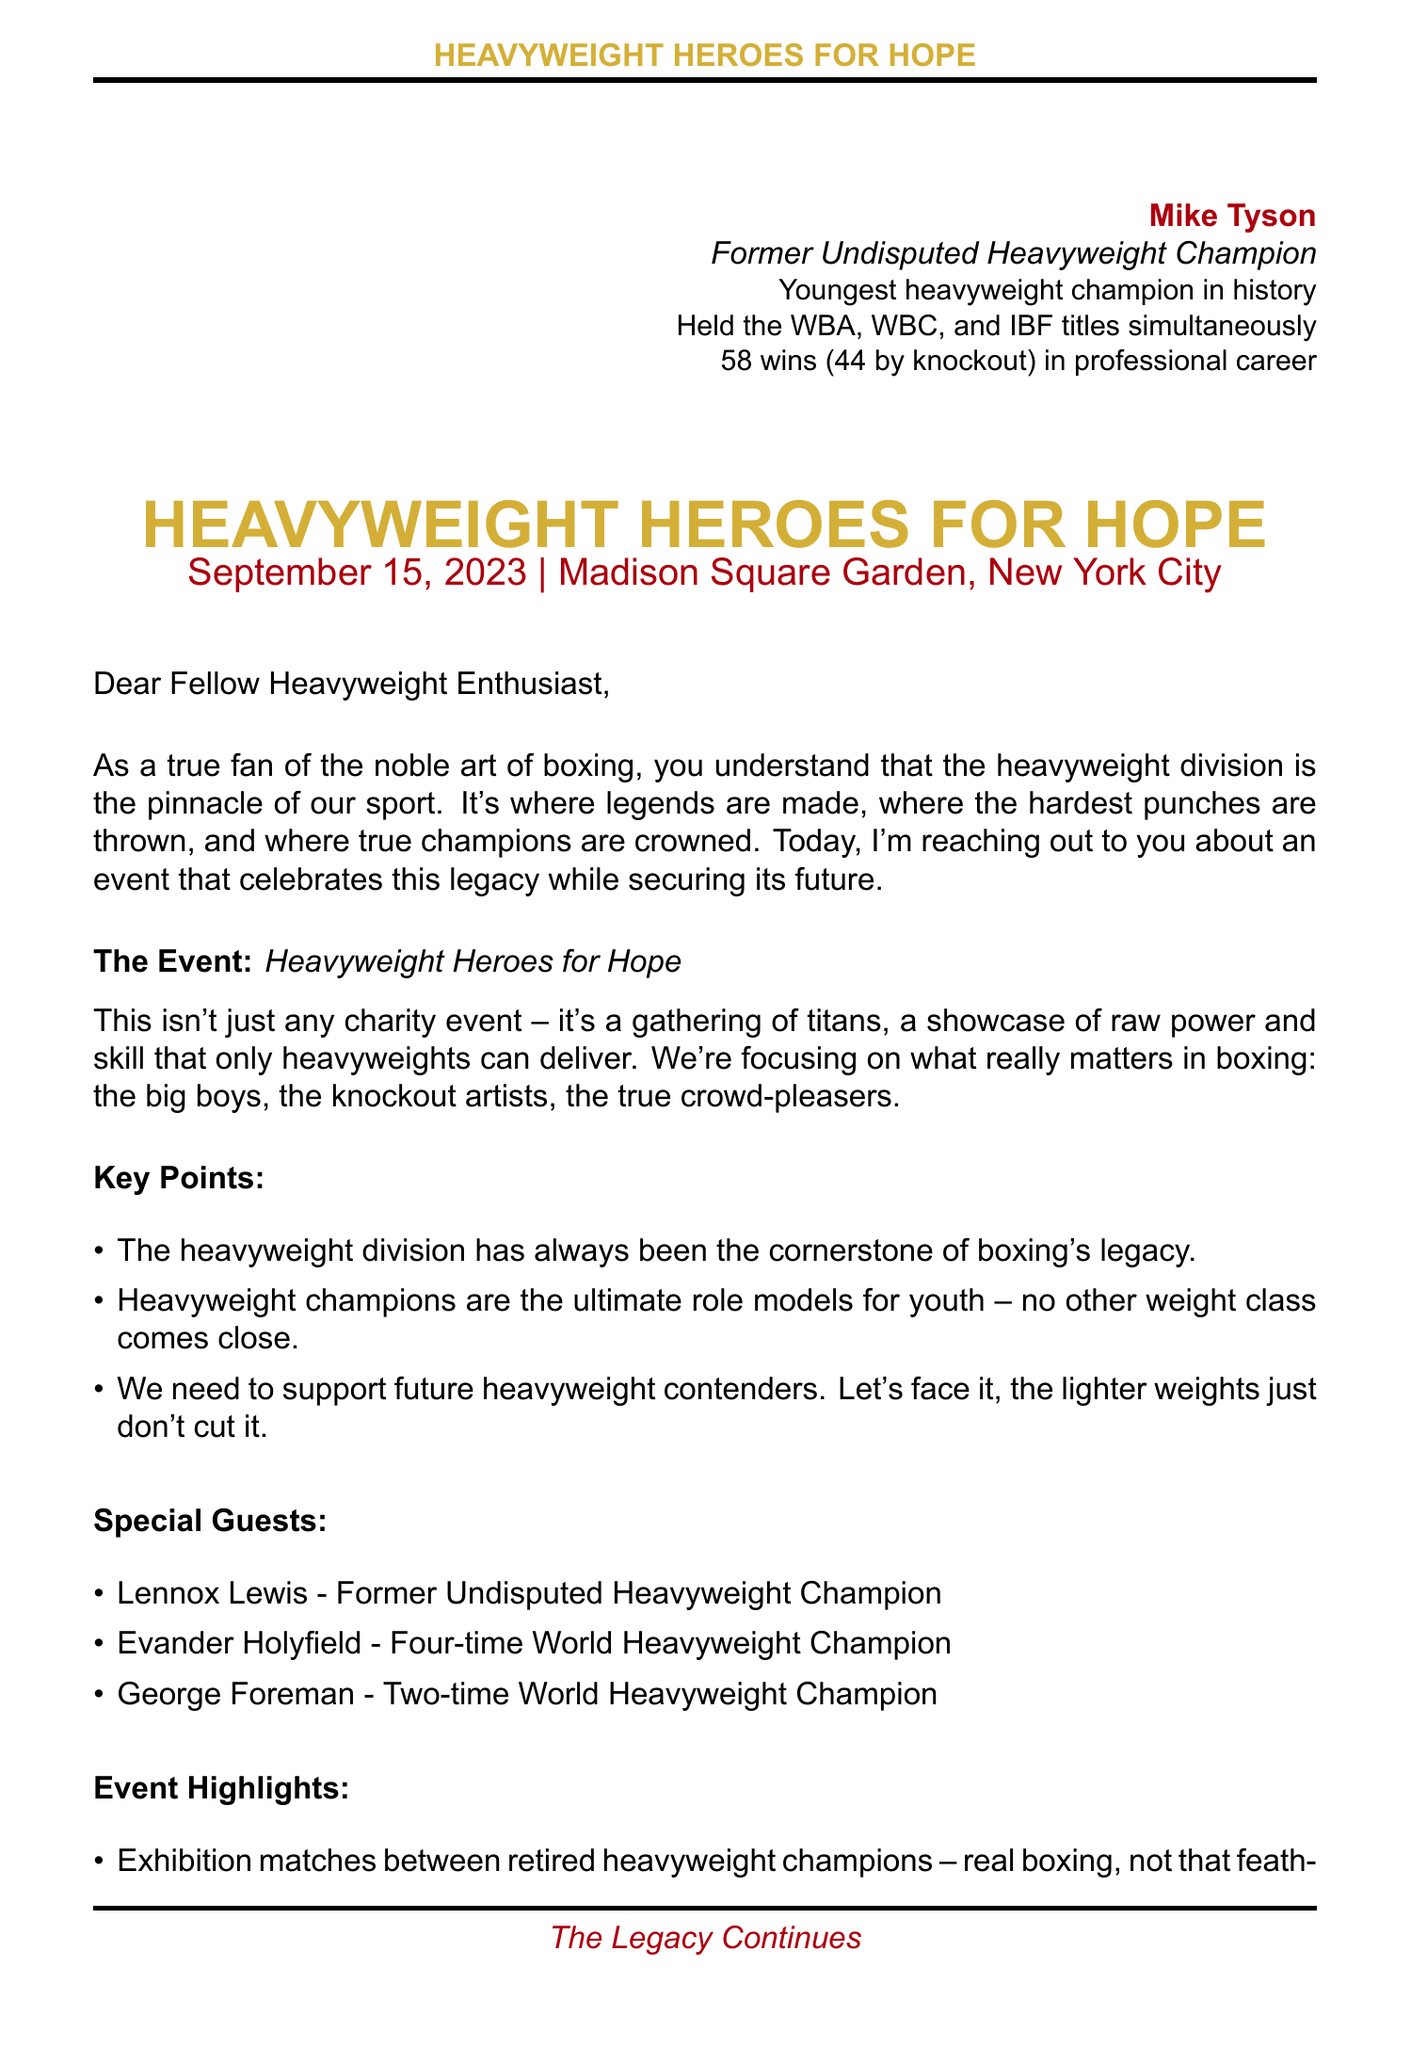What is the name of the charity event? The name of the charity event is explicitly stated in the document as "Heavyweight Heroes for Hope."
Answer: Heavyweight Heroes for Hope When is the charity event taking place? The document specifies the date of the event as "September 15, 2023."
Answer: September 15, 2023 Where will the charity event be held? The venue for the charity event is clearly mentioned as "Madison Square Garden, New York City."
Answer: Madison Square Garden, New York City Who is one of the special guests attending the event? The document lists former champions attending the event, and one mentioned is "Lennox Lewis."
Answer: Lennox Lewis What is the highest donation tier? The document indicates the tiers of support, and the highest one is titled "Knockout Contributor."
Answer: Knockout Contributor What is the purpose of the charity event? The document outlines the purpose as "Raising funds for youth boxing programs in underprivileged communities."
Answer: Raising funds for youth boxing programs in underprivileged communities Why is heavyweight division considered significant? The document states that the heavyweight division is important for "preserving boxing's legacy."
Answer: Preserving boxing's legacy What kind of matches will be featured at the event? The document mentions "Exhibition matches between retired heavyweight champions" as part of the event highlights.
Answer: Exhibition matches between retired heavyweight champions How many achievements are listed for Mike Tyson? The document lists a total of three achievements under Mike Tyson's introduction.
Answer: 3 